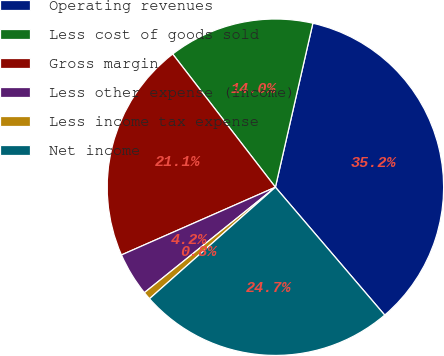<chart> <loc_0><loc_0><loc_500><loc_500><pie_chart><fcel>Operating revenues<fcel>Less cost of goods sold<fcel>Gross margin<fcel>Less other expense (income)<fcel>Less income tax expense<fcel>Net income<nl><fcel>35.17%<fcel>14.03%<fcel>21.14%<fcel>4.19%<fcel>0.75%<fcel>24.72%<nl></chart> 